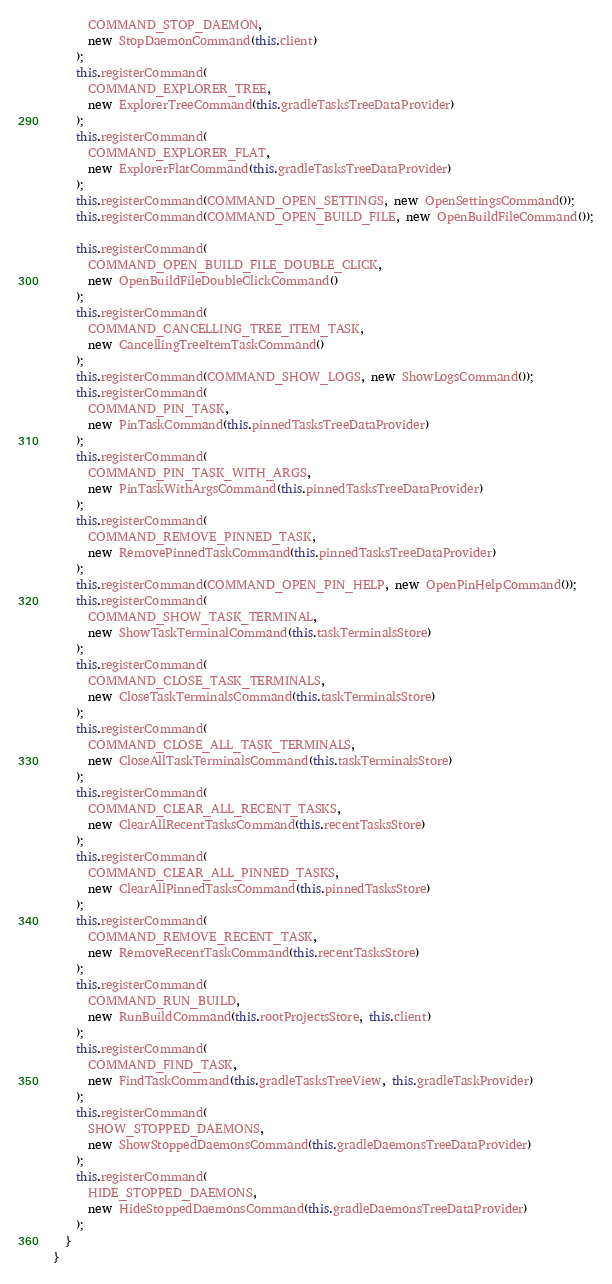Convert code to text. <code><loc_0><loc_0><loc_500><loc_500><_TypeScript_>      COMMAND_STOP_DAEMON,
      new StopDaemonCommand(this.client)
    );
    this.registerCommand(
      COMMAND_EXPLORER_TREE,
      new ExplorerTreeCommand(this.gradleTasksTreeDataProvider)
    );
    this.registerCommand(
      COMMAND_EXPLORER_FLAT,
      new ExplorerFlatCommand(this.gradleTasksTreeDataProvider)
    );
    this.registerCommand(COMMAND_OPEN_SETTINGS, new OpenSettingsCommand());
    this.registerCommand(COMMAND_OPEN_BUILD_FILE, new OpenBuildFileCommand());

    this.registerCommand(
      COMMAND_OPEN_BUILD_FILE_DOUBLE_CLICK,
      new OpenBuildFileDoubleClickCommand()
    );
    this.registerCommand(
      COMMAND_CANCELLING_TREE_ITEM_TASK,
      new CancellingTreeItemTaskCommand()
    );
    this.registerCommand(COMMAND_SHOW_LOGS, new ShowLogsCommand());
    this.registerCommand(
      COMMAND_PIN_TASK,
      new PinTaskCommand(this.pinnedTasksTreeDataProvider)
    );
    this.registerCommand(
      COMMAND_PIN_TASK_WITH_ARGS,
      new PinTaskWithArgsCommand(this.pinnedTasksTreeDataProvider)
    );
    this.registerCommand(
      COMMAND_REMOVE_PINNED_TASK,
      new RemovePinnedTaskCommand(this.pinnedTasksTreeDataProvider)
    );
    this.registerCommand(COMMAND_OPEN_PIN_HELP, new OpenPinHelpCommand());
    this.registerCommand(
      COMMAND_SHOW_TASK_TERMINAL,
      new ShowTaskTerminalCommand(this.taskTerminalsStore)
    );
    this.registerCommand(
      COMMAND_CLOSE_TASK_TERMINALS,
      new CloseTaskTerminalsCommand(this.taskTerminalsStore)
    );
    this.registerCommand(
      COMMAND_CLOSE_ALL_TASK_TERMINALS,
      new CloseAllTaskTerminalsCommand(this.taskTerminalsStore)
    );
    this.registerCommand(
      COMMAND_CLEAR_ALL_RECENT_TASKS,
      new ClearAllRecentTasksCommand(this.recentTasksStore)
    );
    this.registerCommand(
      COMMAND_CLEAR_ALL_PINNED_TASKS,
      new ClearAllPinnedTasksCommand(this.pinnedTasksStore)
    );
    this.registerCommand(
      COMMAND_REMOVE_RECENT_TASK,
      new RemoveRecentTaskCommand(this.recentTasksStore)
    );
    this.registerCommand(
      COMMAND_RUN_BUILD,
      new RunBuildCommand(this.rootProjectsStore, this.client)
    );
    this.registerCommand(
      COMMAND_FIND_TASK,
      new FindTaskCommand(this.gradleTasksTreeView, this.gradleTaskProvider)
    );
    this.registerCommand(
      SHOW_STOPPED_DAEMONS,
      new ShowStoppedDaemonsCommand(this.gradleDaemonsTreeDataProvider)
    );
    this.registerCommand(
      HIDE_STOPPED_DAEMONS,
      new HideStoppedDaemonsCommand(this.gradleDaemonsTreeDataProvider)
    );
  }
}
</code> 